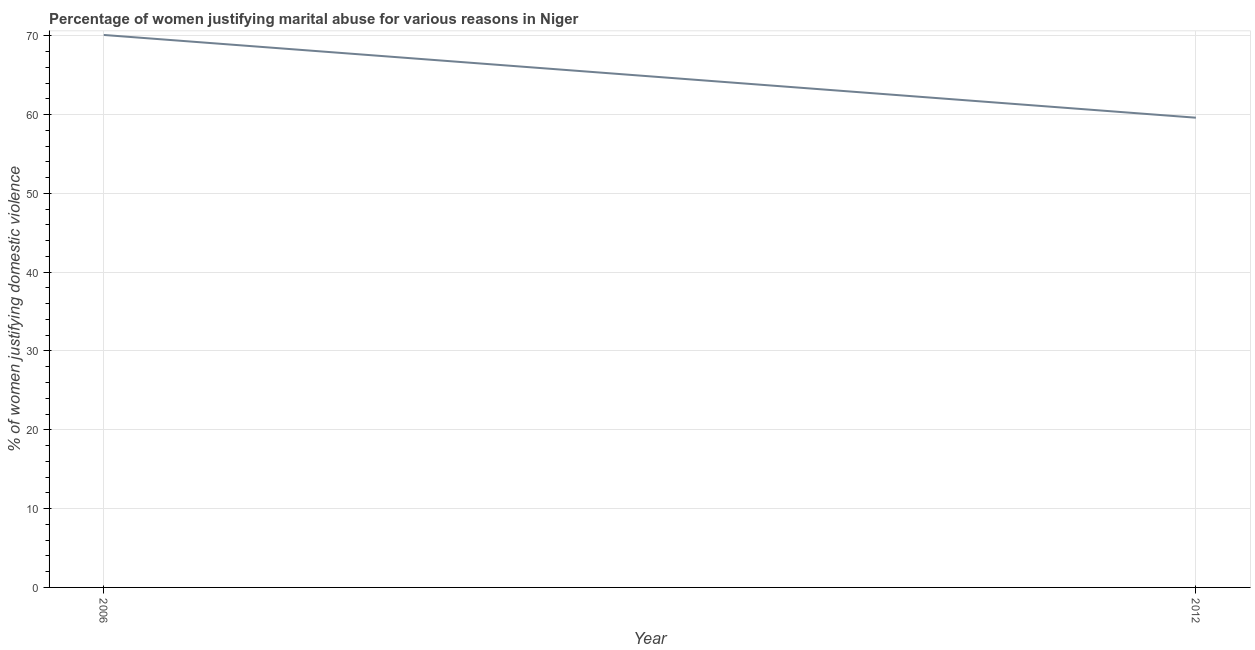What is the percentage of women justifying marital abuse in 2012?
Keep it short and to the point. 59.6. Across all years, what is the maximum percentage of women justifying marital abuse?
Keep it short and to the point. 70.1. Across all years, what is the minimum percentage of women justifying marital abuse?
Provide a short and direct response. 59.6. What is the sum of the percentage of women justifying marital abuse?
Provide a short and direct response. 129.7. What is the difference between the percentage of women justifying marital abuse in 2006 and 2012?
Keep it short and to the point. 10.5. What is the average percentage of women justifying marital abuse per year?
Your answer should be compact. 64.85. What is the median percentage of women justifying marital abuse?
Offer a very short reply. 64.85. In how many years, is the percentage of women justifying marital abuse greater than 38 %?
Your answer should be very brief. 2. Do a majority of the years between 2006 and 2012 (inclusive) have percentage of women justifying marital abuse greater than 42 %?
Ensure brevity in your answer.  Yes. What is the ratio of the percentage of women justifying marital abuse in 2006 to that in 2012?
Your answer should be compact. 1.18. How many lines are there?
Offer a very short reply. 1. Does the graph contain grids?
Your answer should be compact. Yes. What is the title of the graph?
Provide a succinct answer. Percentage of women justifying marital abuse for various reasons in Niger. What is the label or title of the Y-axis?
Offer a very short reply. % of women justifying domestic violence. What is the % of women justifying domestic violence in 2006?
Provide a succinct answer. 70.1. What is the % of women justifying domestic violence in 2012?
Provide a short and direct response. 59.6. What is the difference between the % of women justifying domestic violence in 2006 and 2012?
Provide a succinct answer. 10.5. What is the ratio of the % of women justifying domestic violence in 2006 to that in 2012?
Ensure brevity in your answer.  1.18. 